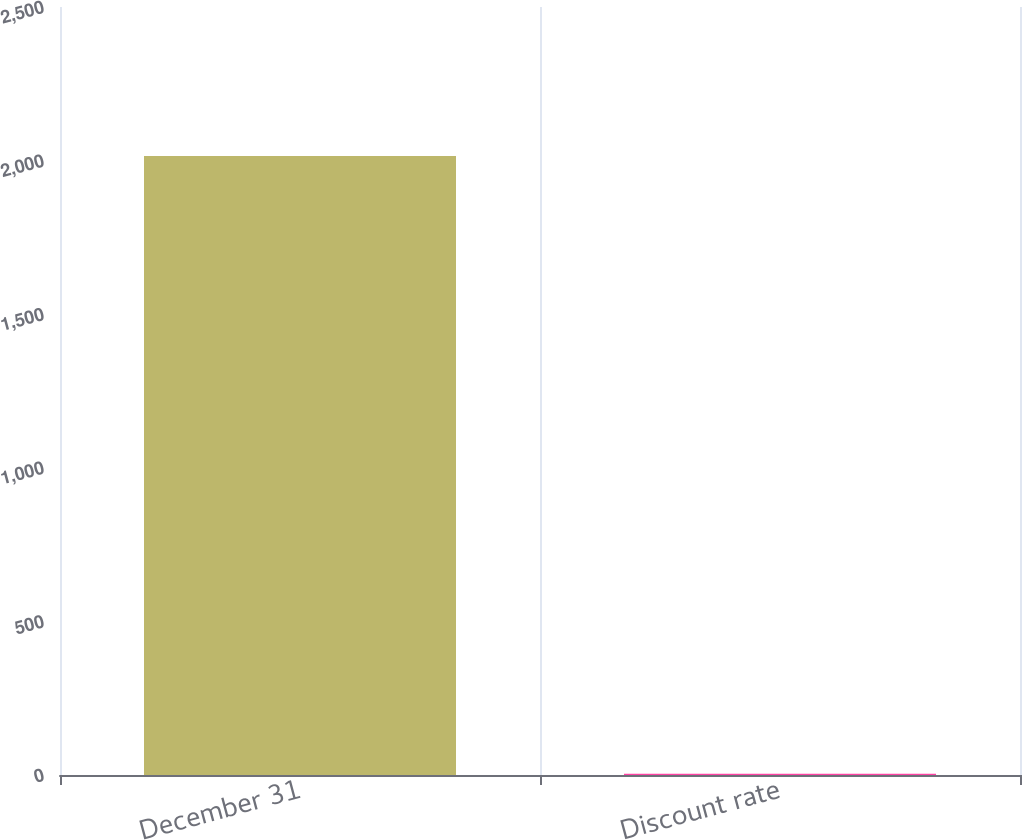Convert chart. <chart><loc_0><loc_0><loc_500><loc_500><bar_chart><fcel>December 31<fcel>Discount rate<nl><fcel>2015<fcel>4.25<nl></chart> 